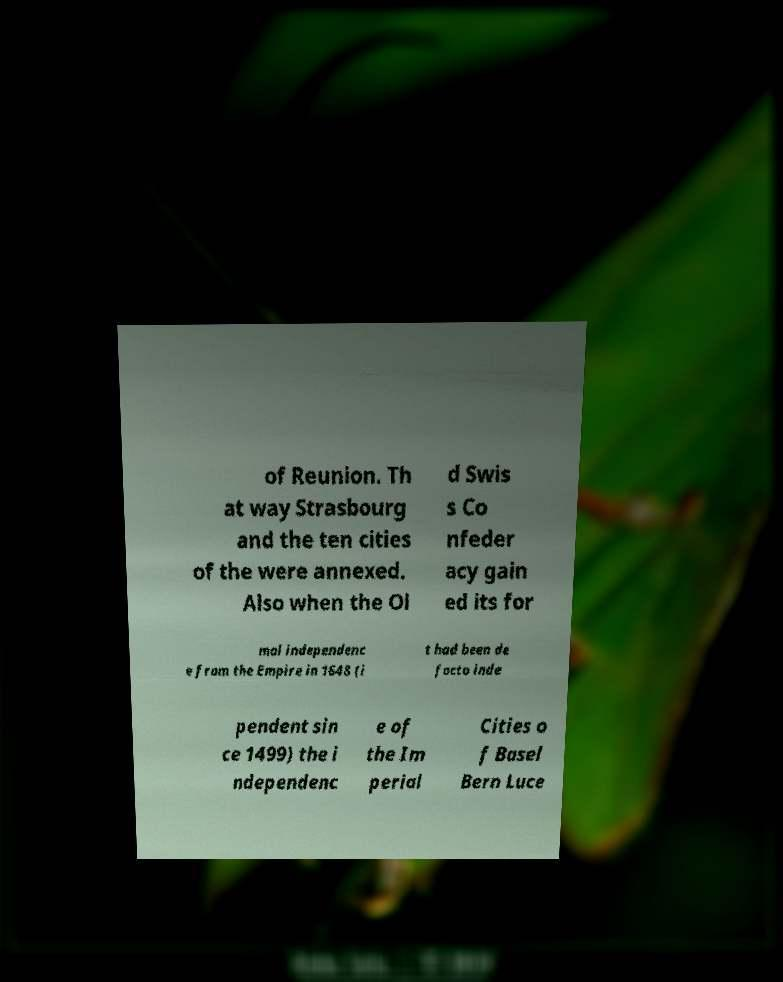For documentation purposes, I need the text within this image transcribed. Could you provide that? of Reunion. Th at way Strasbourg and the ten cities of the were annexed. Also when the Ol d Swis s Co nfeder acy gain ed its for mal independenc e from the Empire in 1648 (i t had been de facto inde pendent sin ce 1499) the i ndependenc e of the Im perial Cities o f Basel Bern Luce 